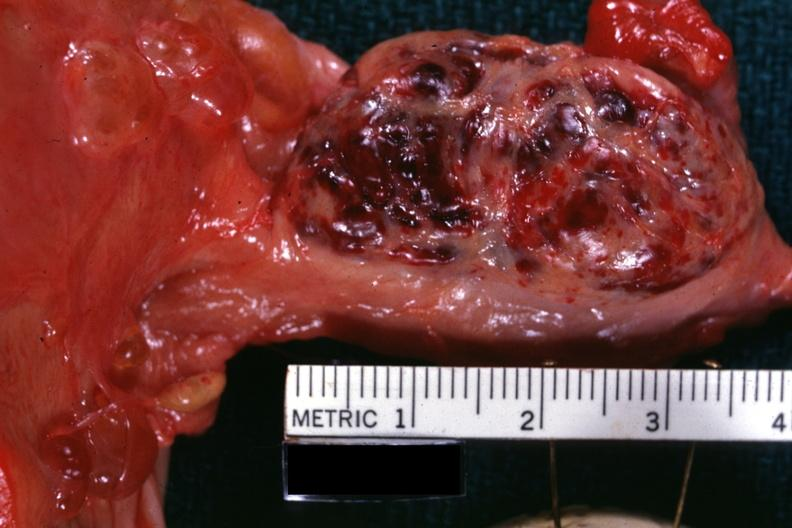what is present?
Answer the question using a single word or phrase. Ovary 